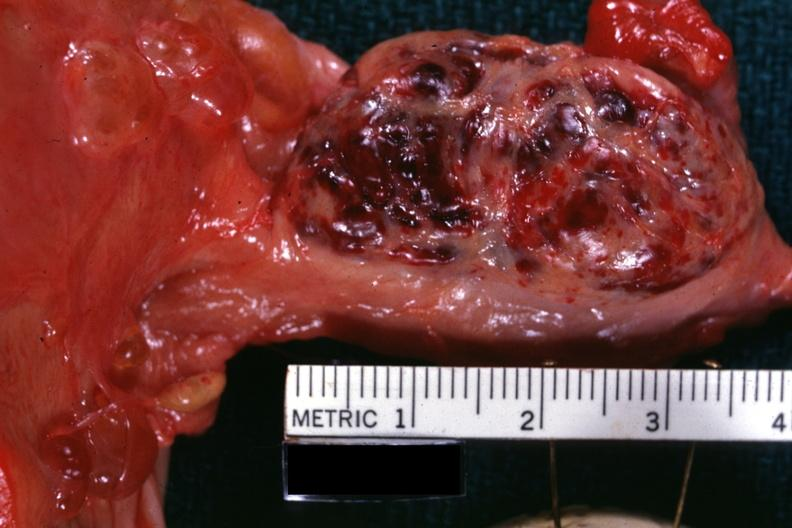what is present?
Answer the question using a single word or phrase. Ovary 